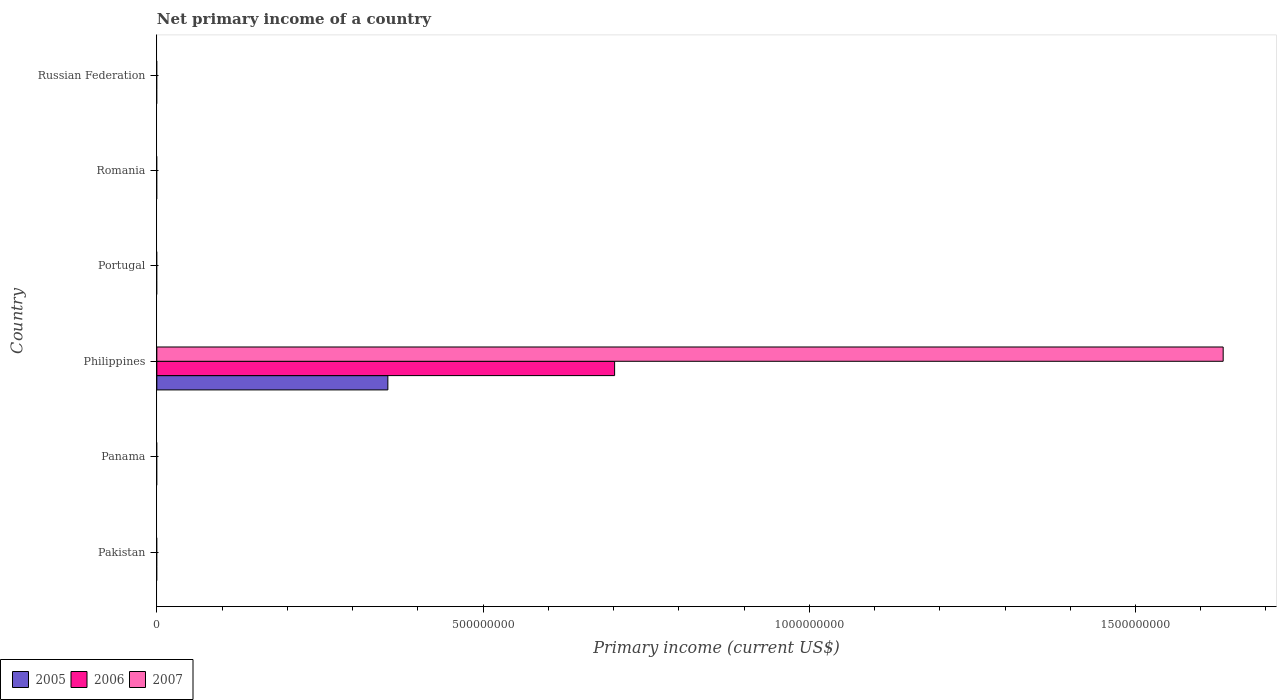Are the number of bars per tick equal to the number of legend labels?
Your response must be concise. No. Are the number of bars on each tick of the Y-axis equal?
Give a very brief answer. No. What is the label of the 5th group of bars from the top?
Your answer should be very brief. Panama. What is the primary income in 2005 in Pakistan?
Give a very brief answer. 0. Across all countries, what is the maximum primary income in 2007?
Give a very brief answer. 1.63e+09. Across all countries, what is the minimum primary income in 2007?
Your answer should be very brief. 0. What is the total primary income in 2007 in the graph?
Your response must be concise. 1.63e+09. What is the average primary income in 2007 per country?
Provide a succinct answer. 2.72e+08. What is the difference between the primary income in 2006 and primary income in 2005 in Philippines?
Give a very brief answer. 3.48e+08. In how many countries, is the primary income in 2006 greater than 1500000000 US$?
Keep it short and to the point. 0. What is the difference between the highest and the lowest primary income in 2007?
Your response must be concise. 1.63e+09. How many countries are there in the graph?
Ensure brevity in your answer.  6. Are the values on the major ticks of X-axis written in scientific E-notation?
Offer a very short reply. No. Does the graph contain grids?
Your answer should be very brief. No. How many legend labels are there?
Your answer should be very brief. 3. What is the title of the graph?
Your answer should be very brief. Net primary income of a country. What is the label or title of the X-axis?
Ensure brevity in your answer.  Primary income (current US$). What is the Primary income (current US$) in 2006 in Pakistan?
Your response must be concise. 0. What is the Primary income (current US$) of 2007 in Pakistan?
Provide a short and direct response. 0. What is the Primary income (current US$) in 2005 in Panama?
Offer a terse response. 0. What is the Primary income (current US$) of 2007 in Panama?
Offer a terse response. 0. What is the Primary income (current US$) in 2005 in Philippines?
Offer a terse response. 3.54e+08. What is the Primary income (current US$) of 2006 in Philippines?
Your answer should be very brief. 7.02e+08. What is the Primary income (current US$) of 2007 in Philippines?
Your response must be concise. 1.63e+09. What is the Primary income (current US$) of 2006 in Portugal?
Your answer should be compact. 0. What is the Primary income (current US$) of 2007 in Portugal?
Keep it short and to the point. 0. What is the Primary income (current US$) of 2005 in Romania?
Provide a short and direct response. 0. Across all countries, what is the maximum Primary income (current US$) in 2005?
Give a very brief answer. 3.54e+08. Across all countries, what is the maximum Primary income (current US$) of 2006?
Your answer should be compact. 7.02e+08. Across all countries, what is the maximum Primary income (current US$) in 2007?
Ensure brevity in your answer.  1.63e+09. Across all countries, what is the minimum Primary income (current US$) of 2005?
Provide a short and direct response. 0. Across all countries, what is the minimum Primary income (current US$) of 2007?
Your answer should be compact. 0. What is the total Primary income (current US$) of 2005 in the graph?
Your answer should be very brief. 3.54e+08. What is the total Primary income (current US$) of 2006 in the graph?
Offer a terse response. 7.02e+08. What is the total Primary income (current US$) of 2007 in the graph?
Your answer should be very brief. 1.63e+09. What is the average Primary income (current US$) in 2005 per country?
Provide a short and direct response. 5.90e+07. What is the average Primary income (current US$) of 2006 per country?
Give a very brief answer. 1.17e+08. What is the average Primary income (current US$) in 2007 per country?
Offer a very short reply. 2.72e+08. What is the difference between the Primary income (current US$) of 2005 and Primary income (current US$) of 2006 in Philippines?
Ensure brevity in your answer.  -3.48e+08. What is the difference between the Primary income (current US$) of 2005 and Primary income (current US$) of 2007 in Philippines?
Make the answer very short. -1.28e+09. What is the difference between the Primary income (current US$) of 2006 and Primary income (current US$) of 2007 in Philippines?
Make the answer very short. -9.33e+08. What is the difference between the highest and the lowest Primary income (current US$) of 2005?
Offer a terse response. 3.54e+08. What is the difference between the highest and the lowest Primary income (current US$) of 2006?
Your response must be concise. 7.02e+08. What is the difference between the highest and the lowest Primary income (current US$) in 2007?
Your response must be concise. 1.63e+09. 